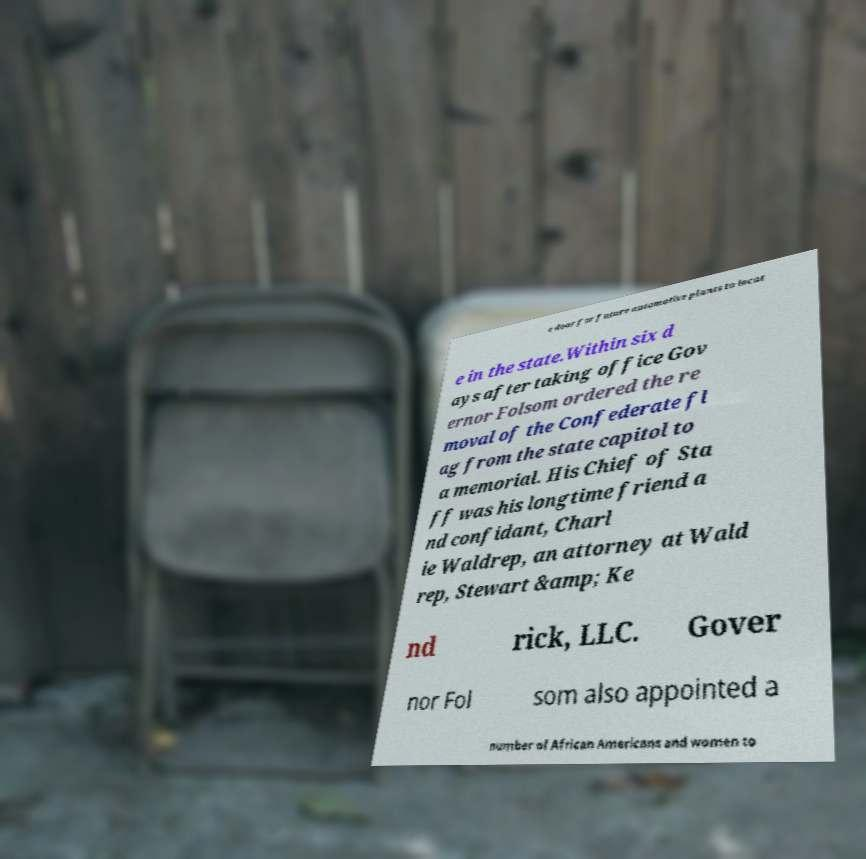Could you extract and type out the text from this image? e door for future automotive plants to locat e in the state.Within six d ays after taking office Gov ernor Folsom ordered the re moval of the Confederate fl ag from the state capitol to a memorial. His Chief of Sta ff was his longtime friend a nd confidant, Charl ie Waldrep, an attorney at Wald rep, Stewart &amp; Ke nd rick, LLC. Gover nor Fol som also appointed a number of African Americans and women to 